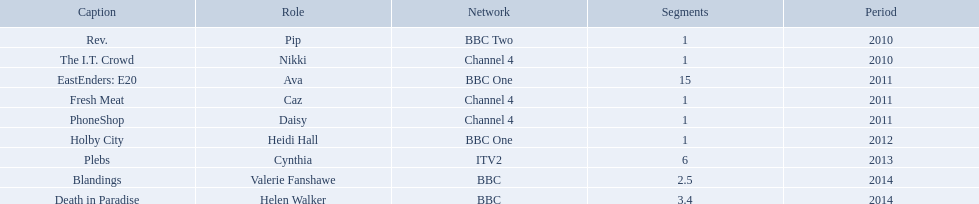Which characters were featured in more then one episode? Ava, Cynthia, Valerie Fanshawe, Helen Walker. Which of these were not in 2014? Ava, Cynthia. Which one of those was not on a bbc broadcaster? Cynthia. 